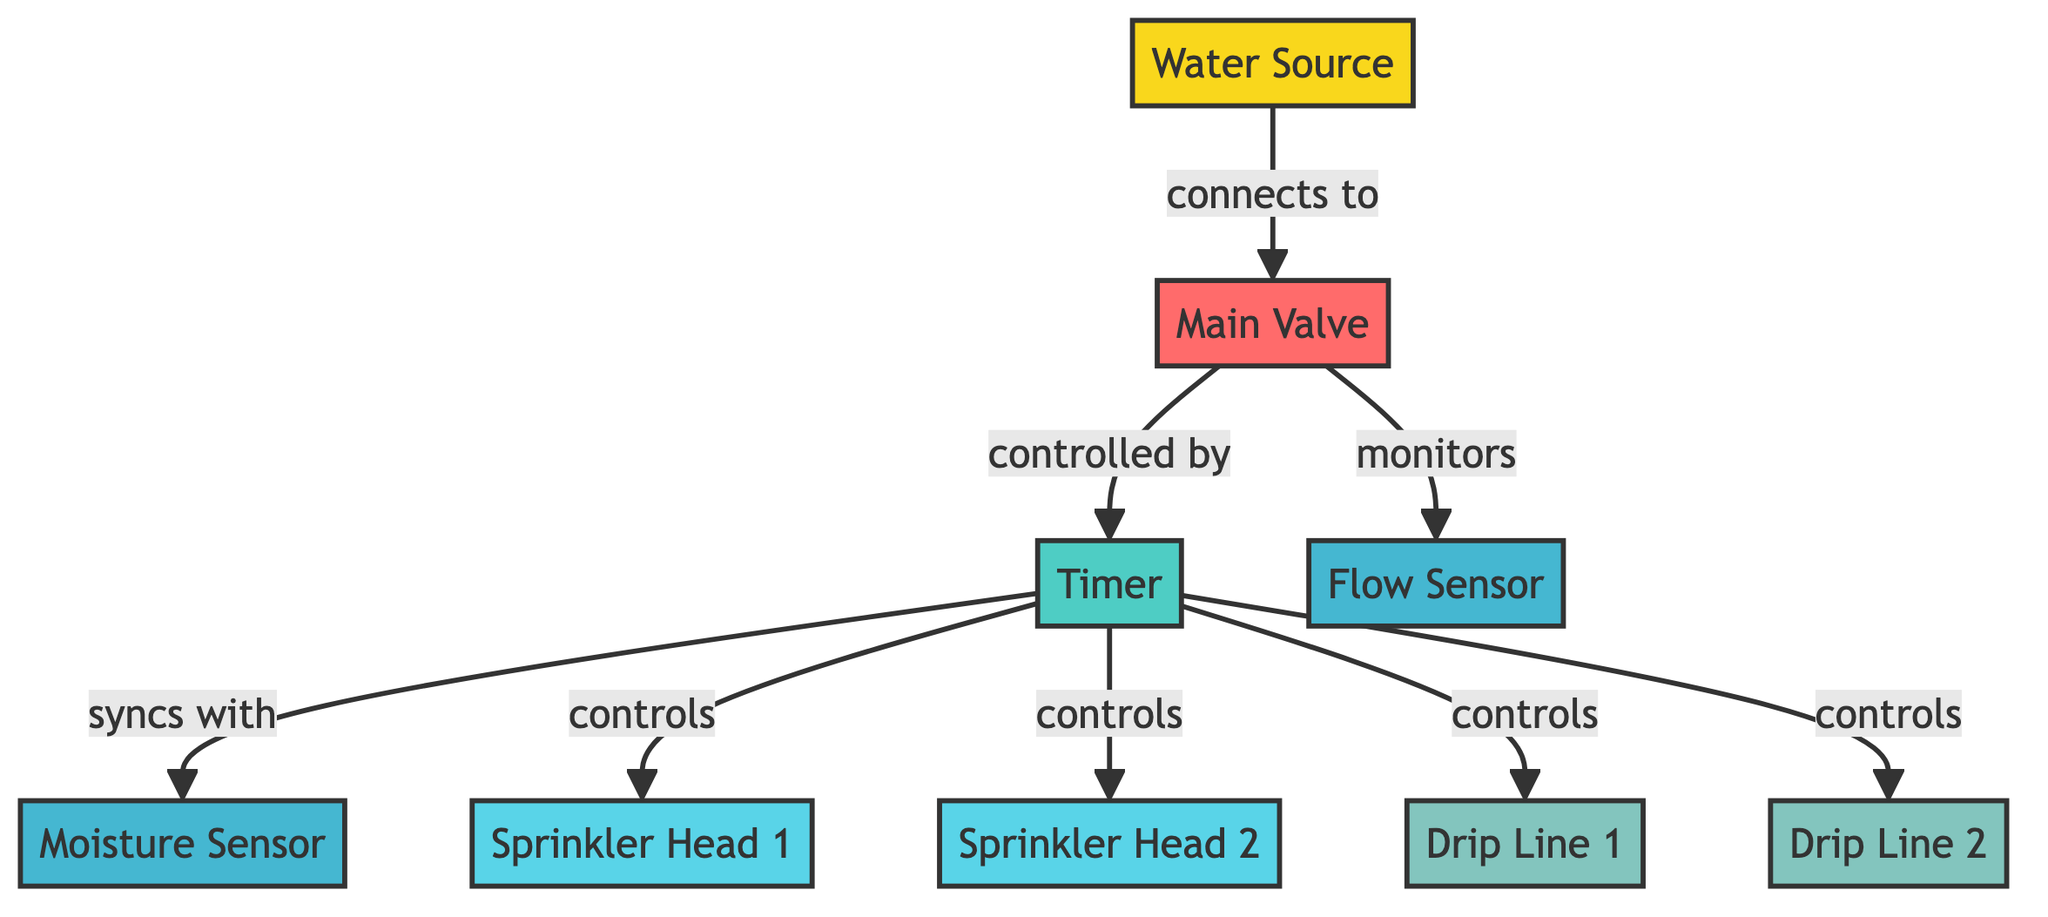What is the main water supply component in the system? The main water supply for the irrigation system is represented by the node labeled "Water Source."
Answer: Water Source How many sprinkler heads are there in the diagram? The diagram displays two nodes labeled "Sprinkler Head 1" and "Sprinkler Head 2," indicating there are two sprinkler heads.
Answer: 2 Which component is controlled by the timer? The timer controls multiple components: "Sprinkler Head 1," "Sprinkler Head 2," "Drip Line 1," and "Drip Line 2." These relationships can be found through the edges that connect the timer to these nodes.
Answer: Sprinkler Head 1, Sprinkler Head 2, Drip Line 1, Drip Line 2 What does the flow sensor monitor? The flow sensor is connected to the "Main Valve" and monitors the flow of water through the system, as indicated by the direct edge labeled "monitors."
Answer: Flow of water What is the purpose of the moisture sensor in this irrigation system? The moisture sensor is linked to the timer, which syncs with it to help optimize watering based on soil moisture levels. This implies its purpose is to provide data for irrigation schedule adjustments.
Answer: Optimize watering How does the main valve relate to the timer? The main valve is controlled by the timer, which is shown by the edge labeled "controlled by." This indicates that the timer manages when the valve opens and closes.
Answer: Controlled by Which two components sync with the timer? The timer syncs with the "Moisture Sensor" and indirectly controls the sprinkler heads and drip lines. The sync relationship with the moisture sensor is indicated directly by the edge labeled "syncs with."
Answer: Moisture Sensor What type of component is the main valve? The main valve is categorized as a valve in the diagram, as noted by its type designation in the node's attributes.
Answer: Valve How many sensors are present in the diagram? The diagram includes two sensor components: the "Moisture Sensor" and the "Flow Sensor." Identifying all nodes of type "sensor" confirms their presence.
Answer: 2 